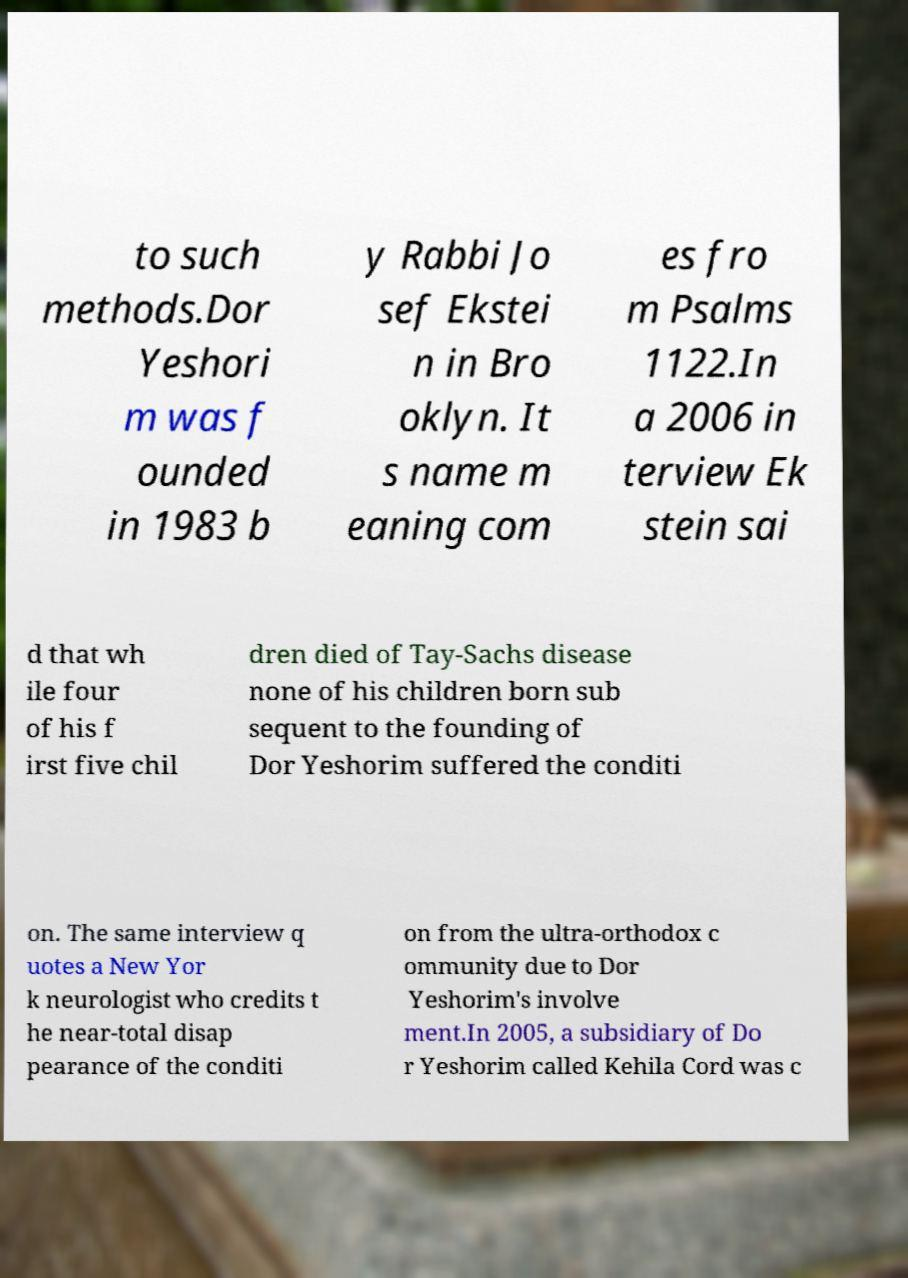I need the written content from this picture converted into text. Can you do that? to such methods.Dor Yeshori m was f ounded in 1983 b y Rabbi Jo sef Ekstei n in Bro oklyn. It s name m eaning com es fro m Psalms 1122.In a 2006 in terview Ek stein sai d that wh ile four of his f irst five chil dren died of Tay-Sachs disease none of his children born sub sequent to the founding of Dor Yeshorim suffered the conditi on. The same interview q uotes a New Yor k neurologist who credits t he near-total disap pearance of the conditi on from the ultra-orthodox c ommunity due to Dor Yeshorim's involve ment.In 2005, a subsidiary of Do r Yeshorim called Kehila Cord was c 